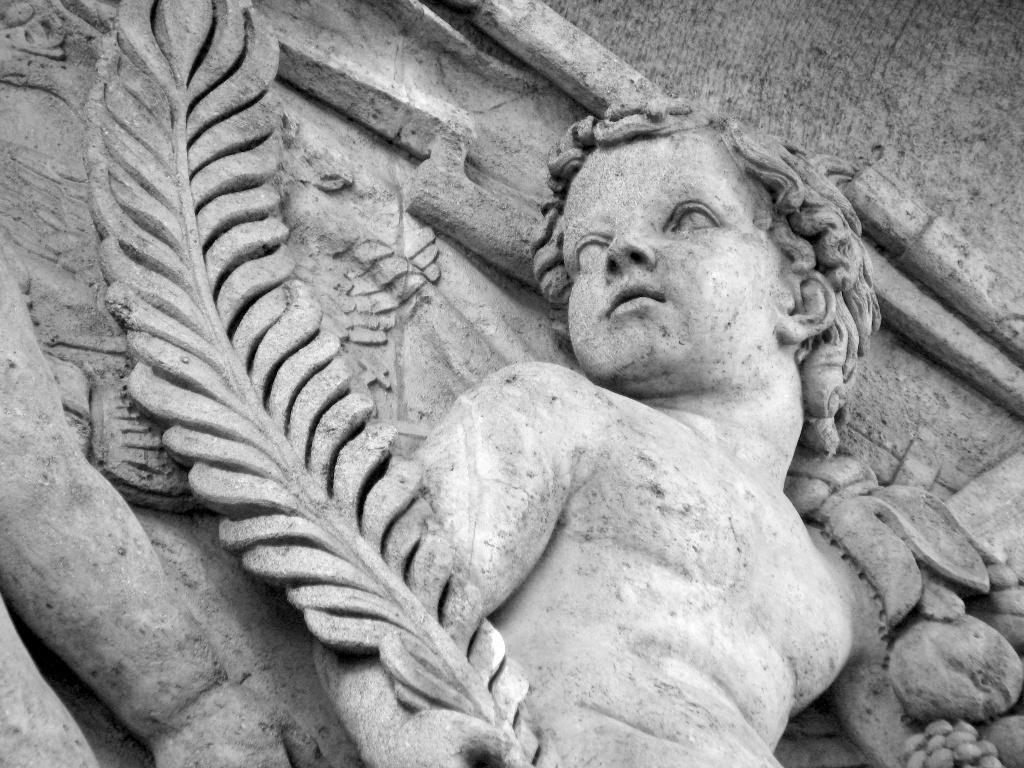Please provide a concise description of this image. In this image I can see the statues of two people which are in ash color. 